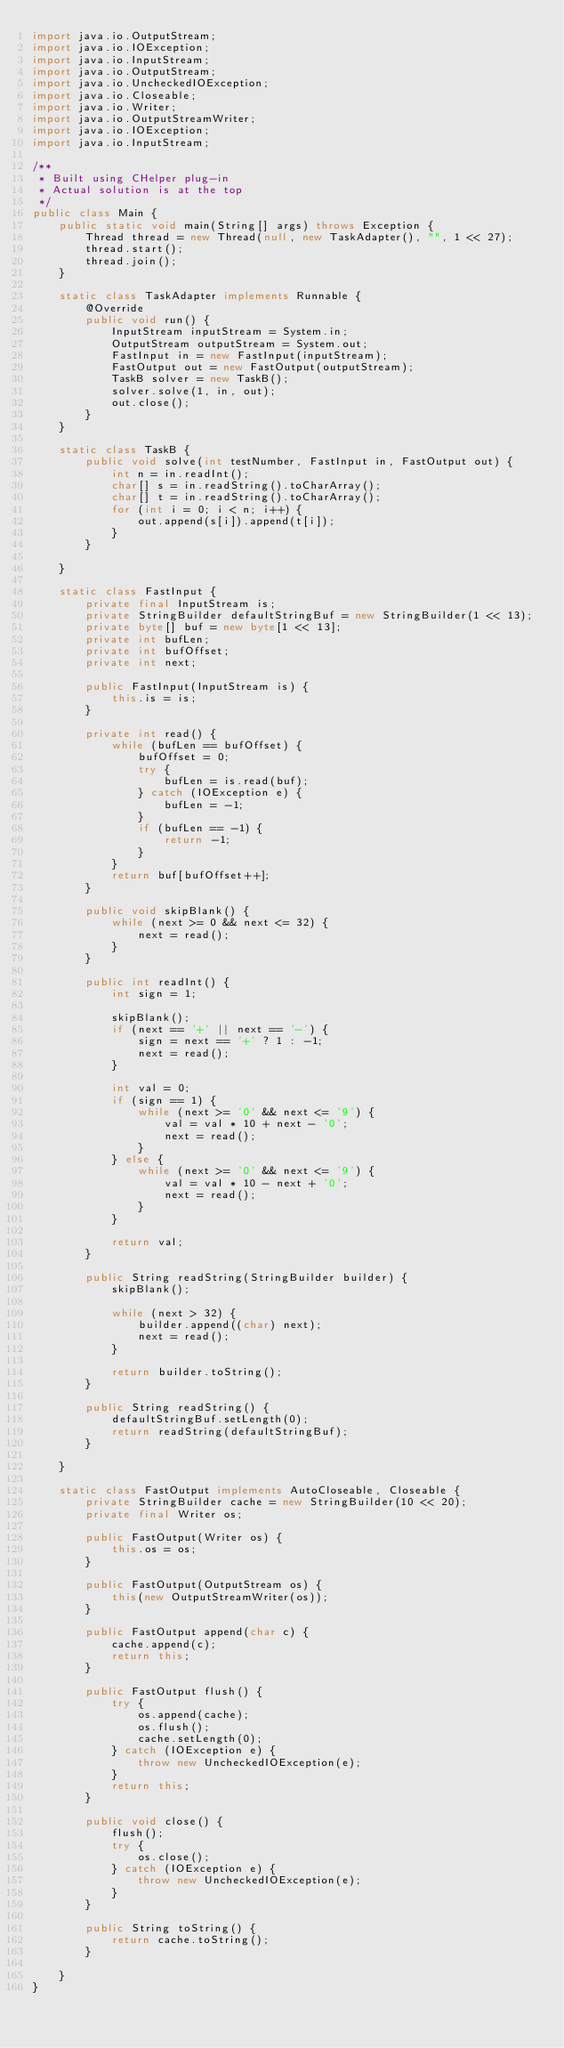<code> <loc_0><loc_0><loc_500><loc_500><_Java_>import java.io.OutputStream;
import java.io.IOException;
import java.io.InputStream;
import java.io.OutputStream;
import java.io.UncheckedIOException;
import java.io.Closeable;
import java.io.Writer;
import java.io.OutputStreamWriter;
import java.io.IOException;
import java.io.InputStream;

/**
 * Built using CHelper plug-in
 * Actual solution is at the top
 */
public class Main {
    public static void main(String[] args) throws Exception {
        Thread thread = new Thread(null, new TaskAdapter(), "", 1 << 27);
        thread.start();
        thread.join();
    }

    static class TaskAdapter implements Runnable {
        @Override
        public void run() {
            InputStream inputStream = System.in;
            OutputStream outputStream = System.out;
            FastInput in = new FastInput(inputStream);
            FastOutput out = new FastOutput(outputStream);
            TaskB solver = new TaskB();
            solver.solve(1, in, out);
            out.close();
        }
    }

    static class TaskB {
        public void solve(int testNumber, FastInput in, FastOutput out) {
            int n = in.readInt();
            char[] s = in.readString().toCharArray();
            char[] t = in.readString().toCharArray();
            for (int i = 0; i < n; i++) {
                out.append(s[i]).append(t[i]);
            }
        }

    }

    static class FastInput {
        private final InputStream is;
        private StringBuilder defaultStringBuf = new StringBuilder(1 << 13);
        private byte[] buf = new byte[1 << 13];
        private int bufLen;
        private int bufOffset;
        private int next;

        public FastInput(InputStream is) {
            this.is = is;
        }

        private int read() {
            while (bufLen == bufOffset) {
                bufOffset = 0;
                try {
                    bufLen = is.read(buf);
                } catch (IOException e) {
                    bufLen = -1;
                }
                if (bufLen == -1) {
                    return -1;
                }
            }
            return buf[bufOffset++];
        }

        public void skipBlank() {
            while (next >= 0 && next <= 32) {
                next = read();
            }
        }

        public int readInt() {
            int sign = 1;

            skipBlank();
            if (next == '+' || next == '-') {
                sign = next == '+' ? 1 : -1;
                next = read();
            }

            int val = 0;
            if (sign == 1) {
                while (next >= '0' && next <= '9') {
                    val = val * 10 + next - '0';
                    next = read();
                }
            } else {
                while (next >= '0' && next <= '9') {
                    val = val * 10 - next + '0';
                    next = read();
                }
            }

            return val;
        }

        public String readString(StringBuilder builder) {
            skipBlank();

            while (next > 32) {
                builder.append((char) next);
                next = read();
            }

            return builder.toString();
        }

        public String readString() {
            defaultStringBuf.setLength(0);
            return readString(defaultStringBuf);
        }

    }

    static class FastOutput implements AutoCloseable, Closeable {
        private StringBuilder cache = new StringBuilder(10 << 20);
        private final Writer os;

        public FastOutput(Writer os) {
            this.os = os;
        }

        public FastOutput(OutputStream os) {
            this(new OutputStreamWriter(os));
        }

        public FastOutput append(char c) {
            cache.append(c);
            return this;
        }

        public FastOutput flush() {
            try {
                os.append(cache);
                os.flush();
                cache.setLength(0);
            } catch (IOException e) {
                throw new UncheckedIOException(e);
            }
            return this;
        }

        public void close() {
            flush();
            try {
                os.close();
            } catch (IOException e) {
                throw new UncheckedIOException(e);
            }
        }

        public String toString() {
            return cache.toString();
        }

    }
}

</code> 